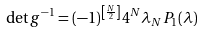Convert formula to latex. <formula><loc_0><loc_0><loc_500><loc_500>\det g ^ { - 1 } = ( - 1 ) ^ { \left [ \frac { N } { 2 } \right ] } 4 ^ { N } \lambda _ { N } P _ { 1 } ( \lambda )</formula> 